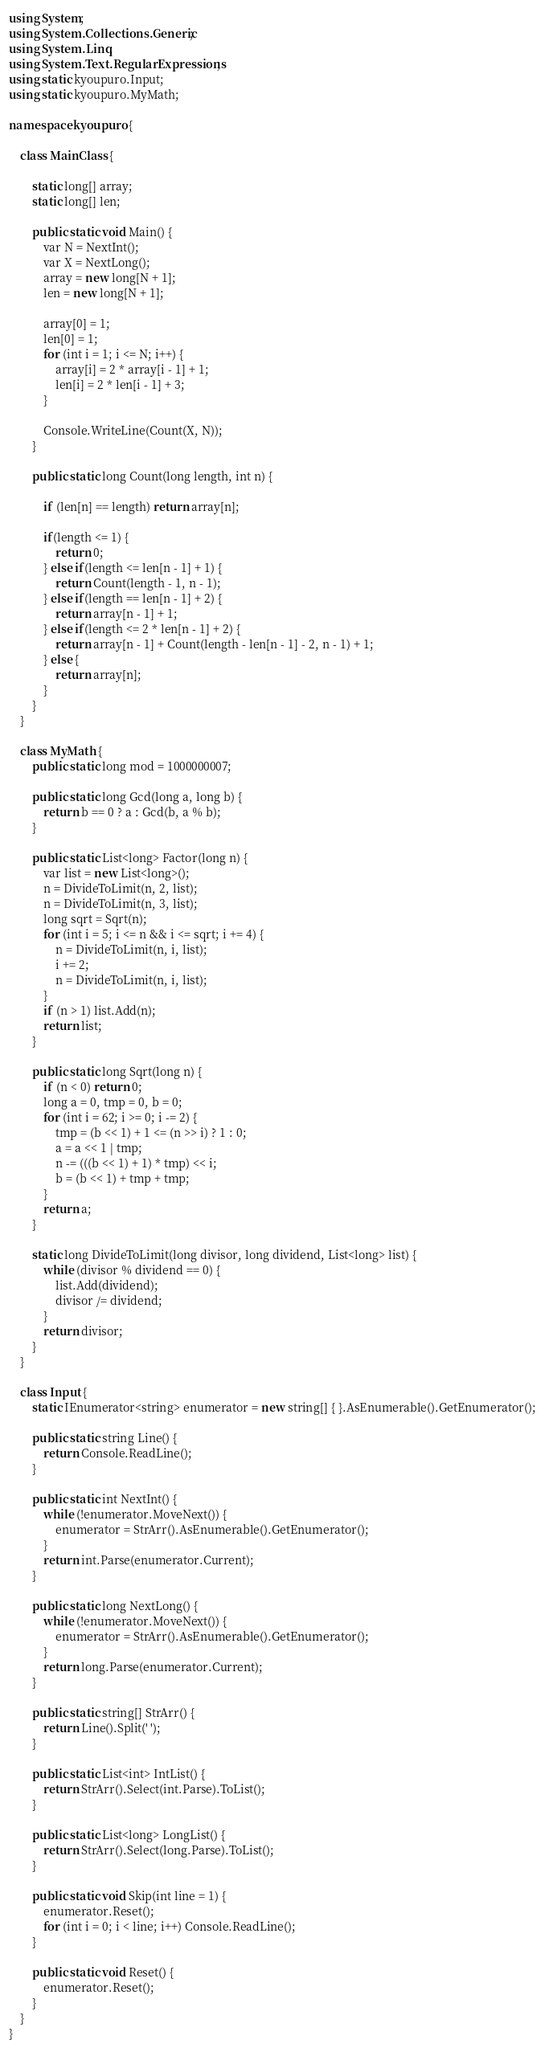<code> <loc_0><loc_0><loc_500><loc_500><_C#_>using System;
using System.Collections.Generic;
using System.Linq;
using System.Text.RegularExpressions;
using static kyoupuro.Input;
using static kyoupuro.MyMath;

namespace kyoupuro {

    class MainClass {

        static long[] array;
        static long[] len;

        public static void Main() {
            var N = NextInt();
            var X = NextLong();
            array = new long[N + 1];
            len = new long[N + 1];

            array[0] = 1;
            len[0] = 1;
            for (int i = 1; i <= N; i++) {
                array[i] = 2 * array[i - 1] + 1;
                len[i] = 2 * len[i - 1] + 3;
            }

            Console.WriteLine(Count(X, N));
        }

        public static long Count(long length, int n) {

            if (len[n] == length) return array[n];
                
            if(length <= 1) {
                return 0;
            } else if(length <= len[n - 1] + 1) {
                return Count(length - 1, n - 1);
            } else if(length == len[n - 1] + 2) {
                return array[n - 1] + 1;
            } else if(length <= 2 * len[n - 1] + 2) {
                return array[n - 1] + Count(length - len[n - 1] - 2, n - 1) + 1;
            } else {
                return array[n];
            }
        }
    }

    class MyMath {
        public static long mod = 1000000007;

        public static long Gcd(long a, long b) {
            return b == 0 ? a : Gcd(b, a % b);
        }

        public static List<long> Factor(long n) {
            var list = new List<long>();
            n = DivideToLimit(n, 2, list);
            n = DivideToLimit(n, 3, list);
            long sqrt = Sqrt(n);
            for (int i = 5; i <= n && i <= sqrt; i += 4) {
                n = DivideToLimit(n, i, list);
                i += 2;
                n = DivideToLimit(n, i, list);
            }
            if (n > 1) list.Add(n);
            return list;
        }

        public static long Sqrt(long n) {
            if (n < 0) return 0;
            long a = 0, tmp = 0, b = 0;
            for (int i = 62; i >= 0; i -= 2) {
                tmp = (b << 1) + 1 <= (n >> i) ? 1 : 0;
                a = a << 1 | tmp;
                n -= (((b << 1) + 1) * tmp) << i;
                b = (b << 1) + tmp + tmp;
            }
            return a;
        }

        static long DivideToLimit(long divisor, long dividend, List<long> list) {
            while (divisor % dividend == 0) {
                list.Add(dividend);
                divisor /= dividend;
            }
            return divisor;
        }
    }

    class Input {
        static IEnumerator<string> enumerator = new string[] { }.AsEnumerable().GetEnumerator();

        public static string Line() {
            return Console.ReadLine();
        }

        public static int NextInt() {
            while (!enumerator.MoveNext()) {
                enumerator = StrArr().AsEnumerable().GetEnumerator();
            }
            return int.Parse(enumerator.Current);
        }

        public static long NextLong() {
            while (!enumerator.MoveNext()) {
                enumerator = StrArr().AsEnumerable().GetEnumerator();
            }
            return long.Parse(enumerator.Current);
        }

        public static string[] StrArr() {
            return Line().Split(' ');
        }

        public static List<int> IntList() {
            return StrArr().Select(int.Parse).ToList();
        }

        public static List<long> LongList() {
            return StrArr().Select(long.Parse).ToList();
        }

        public static void Skip(int line = 1) {
            enumerator.Reset();
            for (int i = 0; i < line; i++) Console.ReadLine();
        }

        public static void Reset() {
            enumerator.Reset();
        }
    }
}</code> 